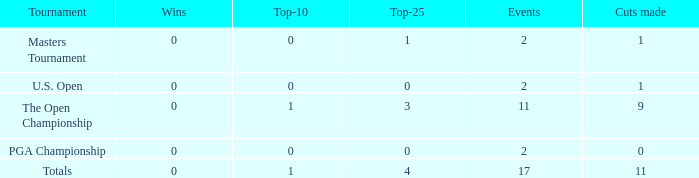What was his win count when he took part in two events? 0.0. 